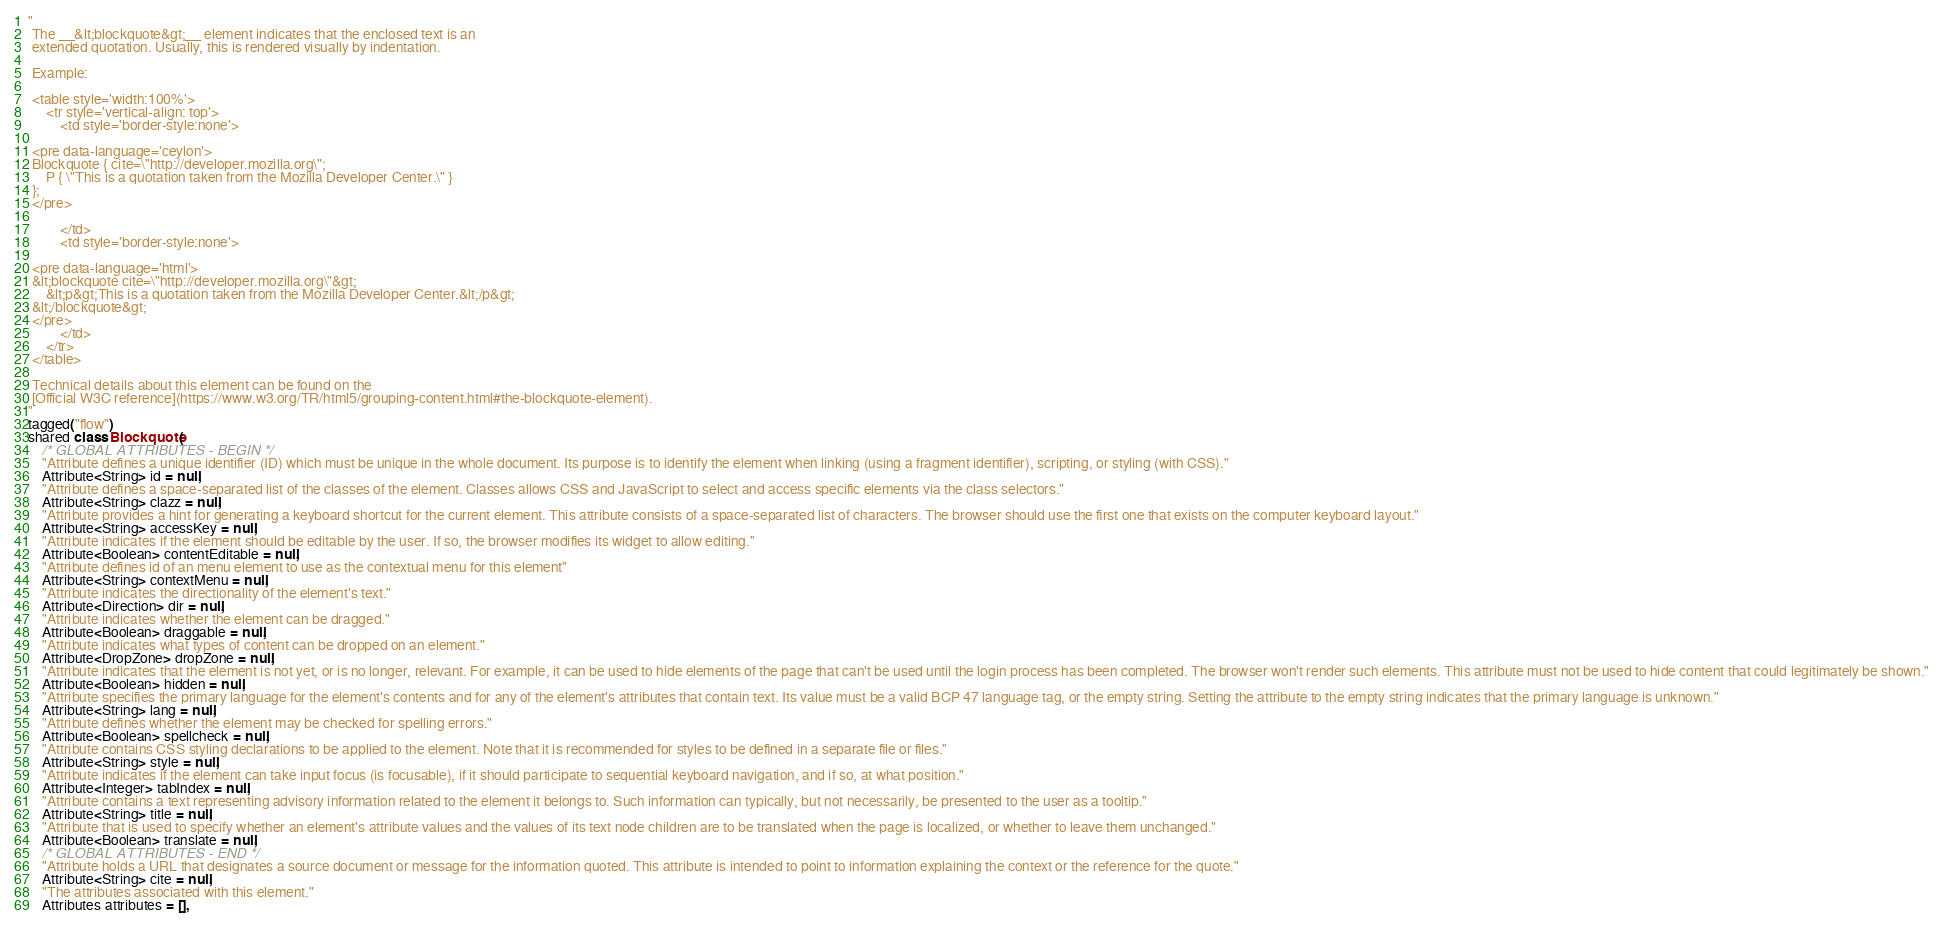Convert code to text. <code><loc_0><loc_0><loc_500><loc_500><_Ceylon_>"
 The __&lt;blockquote&gt;__ element indicates that the enclosed text is an 
 extended quotation. Usually, this is rendered visually by indentation.
 
 Example:
 
 <table style='width:100%'>
     <tr style='vertical-align: top'>
         <td style='border-style:none'>
         
 <pre data-language='ceylon'>
 Blockquote { cite=\"http://developer.mozilla.org\";
     P { \"This is a quotation taken from the Mozilla Developer Center.\" }
 };
 </pre>
 
         </td>
         <td style='border-style:none'>
         
 <pre data-language='html'>
 &lt;blockquote cite=\"http://developer.mozilla.org\"&gt;
     &lt;p&gt;This is a quotation taken from the Mozilla Developer Center.&lt;/p&gt;
 &lt;/blockquote&gt;
 </pre>
         </td>         
     </tr>
 </table>
 
 Technical details about this element can be found on the
 [Official W3C reference](https://www.w3.org/TR/html5/grouping-content.html#the-blockquote-element).
"
tagged("flow")
shared class Blockquote(
    /* GLOBAL ATTRIBUTES - BEGIN */
    "Attribute defines a unique identifier (ID) which must be unique in the whole document. Its purpose is to identify the element when linking (using a fragment identifier), scripting, or styling (with CSS)."
    Attribute<String> id = null,
    "Attribute defines a space-separated list of the classes of the element. Classes allows CSS and JavaScript to select and access specific elements via the class selectors."
    Attribute<String> clazz = null,
    "Attribute provides a hint for generating a keyboard shortcut for the current element. This attribute consists of a space-separated list of characters. The browser should use the first one that exists on the computer keyboard layout."
    Attribute<String> accessKey = null,
    "Attribute indicates if the element should be editable by the user. If so, the browser modifies its widget to allow editing."
    Attribute<Boolean> contentEditable = null,
    "Attribute defines id of an menu element to use as the contextual menu for this element"
    Attribute<String> contextMenu = null,
    "Attribute indicates the directionality of the element's text."
    Attribute<Direction> dir = null,
    "Attribute indicates whether the element can be dragged."
    Attribute<Boolean> draggable = null,
    "Attribute indicates what types of content can be dropped on an element."
    Attribute<DropZone> dropZone = null,
    "Attribute indicates that the element is not yet, or is no longer, relevant. For example, it can be used to hide elements of the page that can't be used until the login process has been completed. The browser won't render such elements. This attribute must not be used to hide content that could legitimately be shown."
    Attribute<Boolean> hidden = null,
    "Attribute specifies the primary language for the element's contents and for any of the element's attributes that contain text. Its value must be a valid BCP 47 language tag, or the empty string. Setting the attribute to the empty string indicates that the primary language is unknown."
    Attribute<String> lang = null,
    "Attribute defines whether the element may be checked for spelling errors."
    Attribute<Boolean> spellcheck = null,
    "Attribute contains CSS styling declarations to be applied to the element. Note that it is recommended for styles to be defined in a separate file or files."
    Attribute<String> style = null,
    "Attribute indicates if the element can take input focus (is focusable), if it should participate to sequential keyboard navigation, and if so, at what position."
    Attribute<Integer> tabIndex = null,
    "Attribute contains a text representing advisory information related to the element it belongs to. Such information can typically, but not necessarily, be presented to the user as a tooltip."
    Attribute<String> title = null,
    "Attribute that is used to specify whether an element's attribute values and the values of its text node children are to be translated when the page is localized, or whether to leave them unchanged."
    Attribute<Boolean> translate = null,
    /* GLOBAL ATTRIBUTES - END */
    "Attribute holds a URL that designates a source document or message for the information quoted. This attribute is intended to point to information explaining the context or the reference for the quote."
    Attribute<String> cite = null,
    "The attributes associated with this element."
    Attributes attributes = [],</code> 